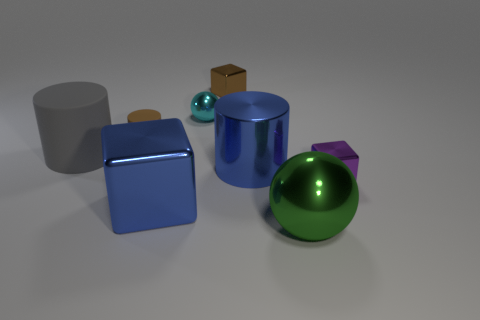Add 1 tiny brown shiny blocks. How many objects exist? 9 Subtract all spheres. How many objects are left? 6 Subtract all red rubber cylinders. Subtract all shiny balls. How many objects are left? 6 Add 6 tiny brown metallic things. How many tiny brown metallic things are left? 7 Add 3 big green rubber balls. How many big green rubber balls exist? 3 Subtract 0 cyan cubes. How many objects are left? 8 